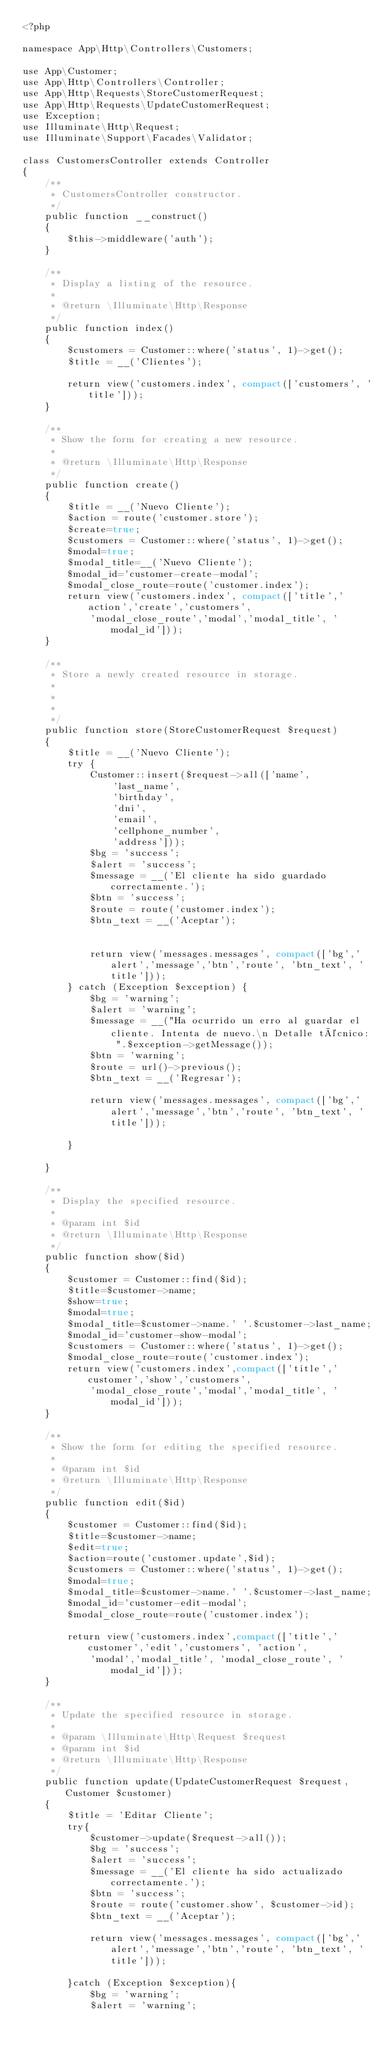<code> <loc_0><loc_0><loc_500><loc_500><_PHP_><?php

namespace App\Http\Controllers\Customers;

use App\Customer;
use App\Http\Controllers\Controller;
use App\Http\Requests\StoreCustomerRequest;
use App\Http\Requests\UpdateCustomerRequest;
use Exception;
use Illuminate\Http\Request;
use Illuminate\Support\Facades\Validator;

class CustomersController extends Controller
{
    /**
     * CustomersController constructor.
     */
    public function __construct()
    {
        $this->middleware('auth');
    }

    /**
     * Display a listing of the resource.
     *
     * @return \Illuminate\Http\Response
     */
    public function index()
    {
        $customers = Customer::where('status', 1)->get();
        $title = __('Clientes');

        return view('customers.index', compact(['customers', 'title']));
    }

    /**
     * Show the form for creating a new resource.
     *
     * @return \Illuminate\Http\Response
     */
    public function create()
    {
        $title = __('Nuevo Cliente');
        $action = route('customer.store');
        $create=true;
        $customers = Customer::where('status', 1)->get();
        $modal=true;
        $modal_title=__('Nuevo Cliente');
        $modal_id='customer-create-modal';
        $modal_close_route=route('customer.index');
        return view('customers.index', compact(['title','action','create','customers',
            'modal_close_route','modal','modal_title', 'modal_id']));
    }

    /**
     * Store a newly created resource in storage.
     *
     *
     *
     */
    public function store(StoreCustomerRequest $request)
    {
        $title = __('Nuevo Cliente');
        try {
            Customer::insert($request->all(['name',
                'last_name',
                'birthday',
                'dni',
                'email',
                'cellphone_number',
                'address']));
            $bg = 'success';
            $alert = 'success';
            $message = __('El cliente ha sido guardado correctamente.');
            $btn = 'success';
            $route = route('customer.index');
            $btn_text = __('Aceptar');


            return view('messages.messages', compact(['bg','alert','message','btn','route', 'btn_text', 'title']));
        } catch (Exception $exception) {
            $bg = 'warning';
            $alert = 'warning';
            $message = __("Ha ocurrido un erro al guardar el cliente. Intenta de nuevo.\n Detalle técnico: ".$exception->getMessage());
            $btn = 'warning';
            $route = url()->previous();
            $btn_text = __('Regresar');

            return view('messages.messages', compact(['bg','alert','message','btn','route', 'btn_text', 'title']));

        }

    }

    /**
     * Display the specified resource.
     *
     * @param int $id
     * @return \Illuminate\Http\Response
     */
    public function show($id)
    {
        $customer = Customer::find($id);
        $title=$customer->name;
        $show=true;
        $modal=true;
        $modal_title=$customer->name.' '.$customer->last_name;
        $modal_id='customer-show-modal';
        $customers = Customer::where('status', 1)->get();
        $modal_close_route=route('customer.index');
        return view('customers.index',compact(['title','customer','show','customers',
            'modal_close_route','modal','modal_title', 'modal_id']));
    }

    /**
     * Show the form for editing the specified resource.
     *
     * @param int $id
     * @return \Illuminate\Http\Response
     */
    public function edit($id)
    {
        $customer = Customer::find($id);
        $title=$customer->name;
        $edit=true;
        $action=route('customer.update',$id);
        $customers = Customer::where('status', 1)->get();
        $modal=true;
        $modal_title=$customer->name.' '.$customer->last_name;
        $modal_id='customer-edit-modal';
        $modal_close_route=route('customer.index');

        return view('customers.index',compact(['title','customer','edit','customers', 'action',
            'modal','modal_title', 'modal_close_route', 'modal_id']));
    }

    /**
     * Update the specified resource in storage.
     *
     * @param \Illuminate\Http\Request $request
     * @param int $id
     * @return \Illuminate\Http\Response
     */
    public function update(UpdateCustomerRequest $request, Customer $customer)
    {
        $title = 'Editar Cliente';
        try{
            $customer->update($request->all());
            $bg = 'success';
            $alert = 'success';
            $message = __('El cliente ha sido actualizado correctamente.');
            $btn = 'success';
            $route = route('customer.show', $customer->id);
            $btn_text = __('Aceptar');

            return view('messages.messages', compact(['bg','alert','message','btn','route', 'btn_text', 'title']));

        }catch (Exception $exception){
            $bg = 'warning';
            $alert = 'warning';</code> 